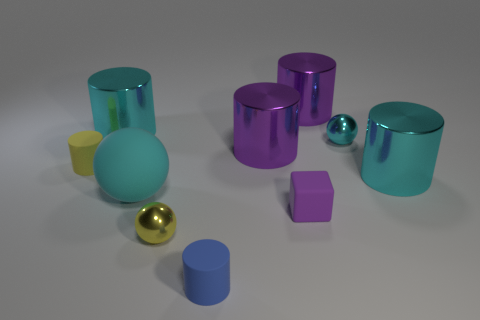Is the number of tiny rubber blocks greater than the number of small red things?
Give a very brief answer. Yes. Is there a thing that is behind the blue rubber object on the left side of the small cyan metallic thing?
Offer a terse response. Yes. There is another small rubber object that is the same shape as the tiny blue object; what is its color?
Provide a succinct answer. Yellow. Is there anything else that is the same shape as the small purple rubber object?
Offer a terse response. No. The large sphere that is made of the same material as the blue thing is what color?
Your answer should be very brief. Cyan. There is a sphere right of the rubber cylinder that is in front of the tiny purple block; is there a cyan metal sphere behind it?
Your answer should be very brief. No. Are there fewer cyan shiny spheres on the left side of the blue cylinder than tiny shiny balls behind the purple rubber cube?
Make the answer very short. Yes. What number of tiny cyan balls have the same material as the cube?
Offer a very short reply. 0. There is a rubber sphere; is its size the same as the metallic object that is in front of the big cyan matte ball?
Your answer should be very brief. No. What is the material of the tiny object that is the same color as the large rubber thing?
Your answer should be very brief. Metal. 